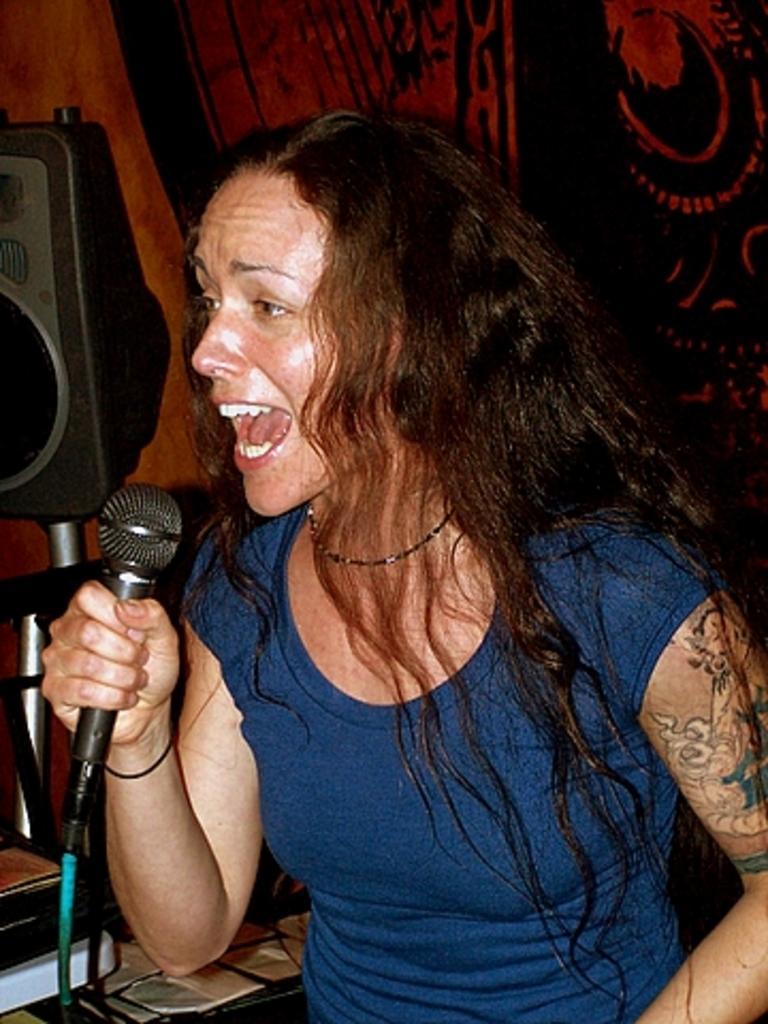How would you summarize this image in a sentence or two? In this picture we can see a woman holding a mike in her hand and singing. This is a tattoo on her hand. 